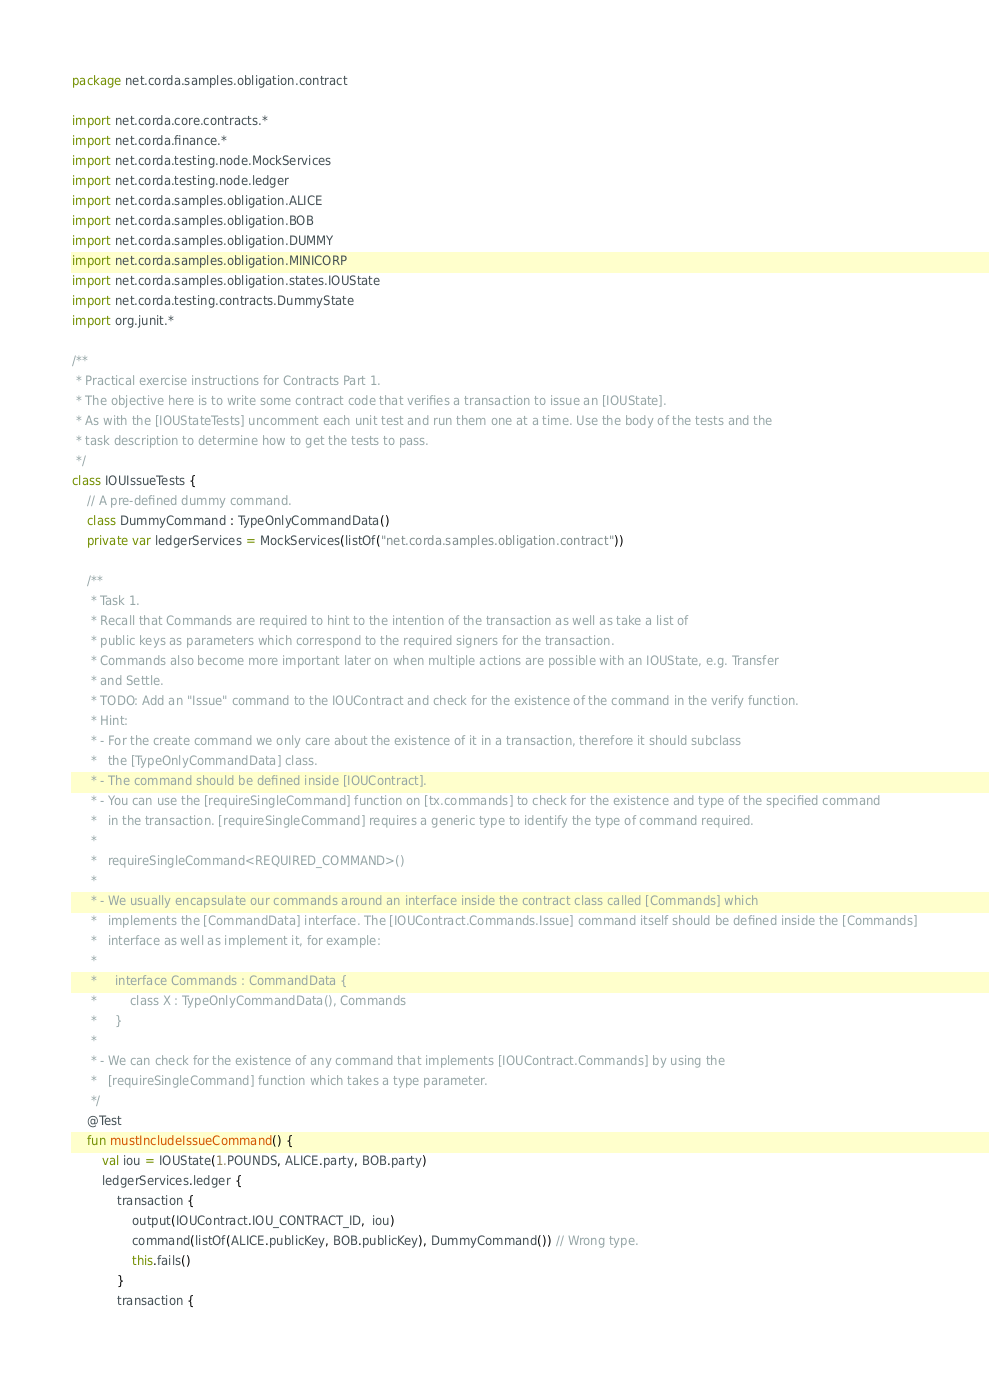<code> <loc_0><loc_0><loc_500><loc_500><_Kotlin_>package net.corda.samples.obligation.contract

import net.corda.core.contracts.*
import net.corda.finance.*
import net.corda.testing.node.MockServices
import net.corda.testing.node.ledger
import net.corda.samples.obligation.ALICE
import net.corda.samples.obligation.BOB
import net.corda.samples.obligation.DUMMY
import net.corda.samples.obligation.MINICORP
import net.corda.samples.obligation.states.IOUState
import net.corda.testing.contracts.DummyState
import org.junit.*

/**
 * Practical exercise instructions for Contracts Part 1.
 * The objective here is to write some contract code that verifies a transaction to issue an [IOUState].
 * As with the [IOUStateTests] uncomment each unit test and run them one at a time. Use the body of the tests and the
 * task description to determine how to get the tests to pass.
 */
class IOUIssueTests {
    // A pre-defined dummy command.
    class DummyCommand : TypeOnlyCommandData()
    private var ledgerServices = MockServices(listOf("net.corda.samples.obligation.contract"))

    /**
     * Task 1.
     * Recall that Commands are required to hint to the intention of the transaction as well as take a list of
     * public keys as parameters which correspond to the required signers for the transaction.
     * Commands also become more important later on when multiple actions are possible with an IOUState, e.g. Transfer
     * and Settle.
     * TODO: Add an "Issue" command to the IOUContract and check for the existence of the command in the verify function.
     * Hint:
     * - For the create command we only care about the existence of it in a transaction, therefore it should subclass
     *   the [TypeOnlyCommandData] class.
     * - The command should be defined inside [IOUContract].
     * - You can use the [requireSingleCommand] function on [tx.commands] to check for the existence and type of the specified command
     *   in the transaction. [requireSingleCommand] requires a generic type to identify the type of command required.
     *
     *   requireSingleCommand<REQUIRED_COMMAND>()
     *
     * - We usually encapsulate our commands around an interface inside the contract class called [Commands] which
     *   implements the [CommandData] interface. The [IOUContract.Commands.Issue] command itself should be defined inside the [Commands]
     *   interface as well as implement it, for example:
     *
     *     interface Commands : CommandData {
     *         class X : TypeOnlyCommandData(), Commands
     *     }
     *
     * - We can check for the existence of any command that implements [IOUContract.Commands] by using the
     *   [requireSingleCommand] function which takes a type parameter.
     */
    @Test
    fun mustIncludeIssueCommand() {
        val iou = IOUState(1.POUNDS, ALICE.party, BOB.party)
        ledgerServices.ledger {
            transaction {
                output(IOUContract.IOU_CONTRACT_ID,  iou)
                command(listOf(ALICE.publicKey, BOB.publicKey), DummyCommand()) // Wrong type.
                this.fails()
            }
            transaction {</code> 